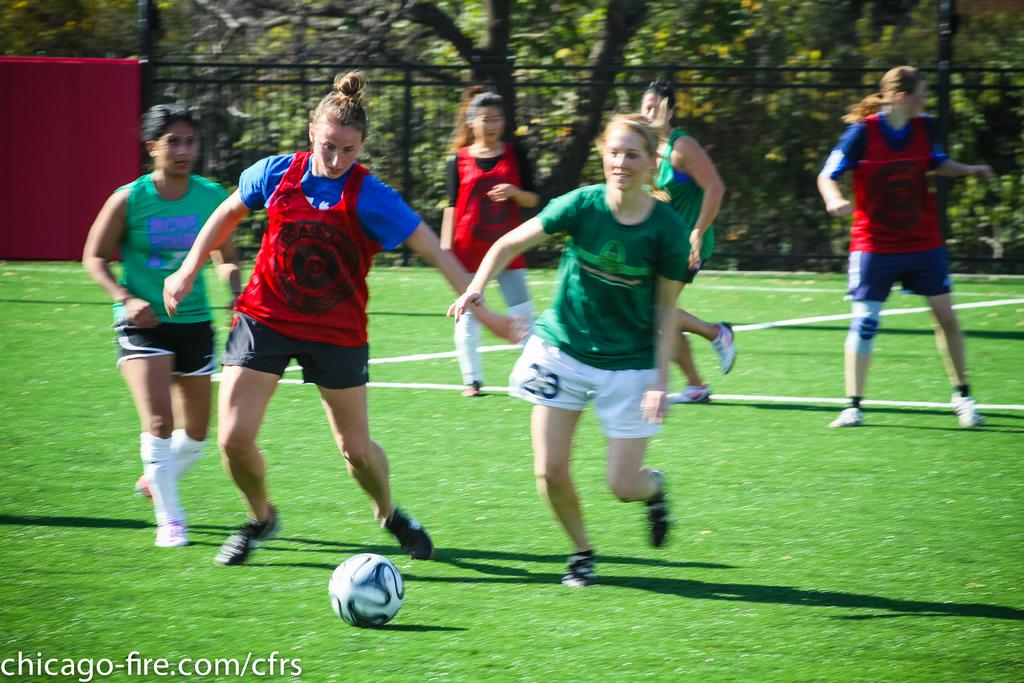Provide a one-sentence caption for the provided image. Young women playing soccer in red and green teams, one girl is number 23. 